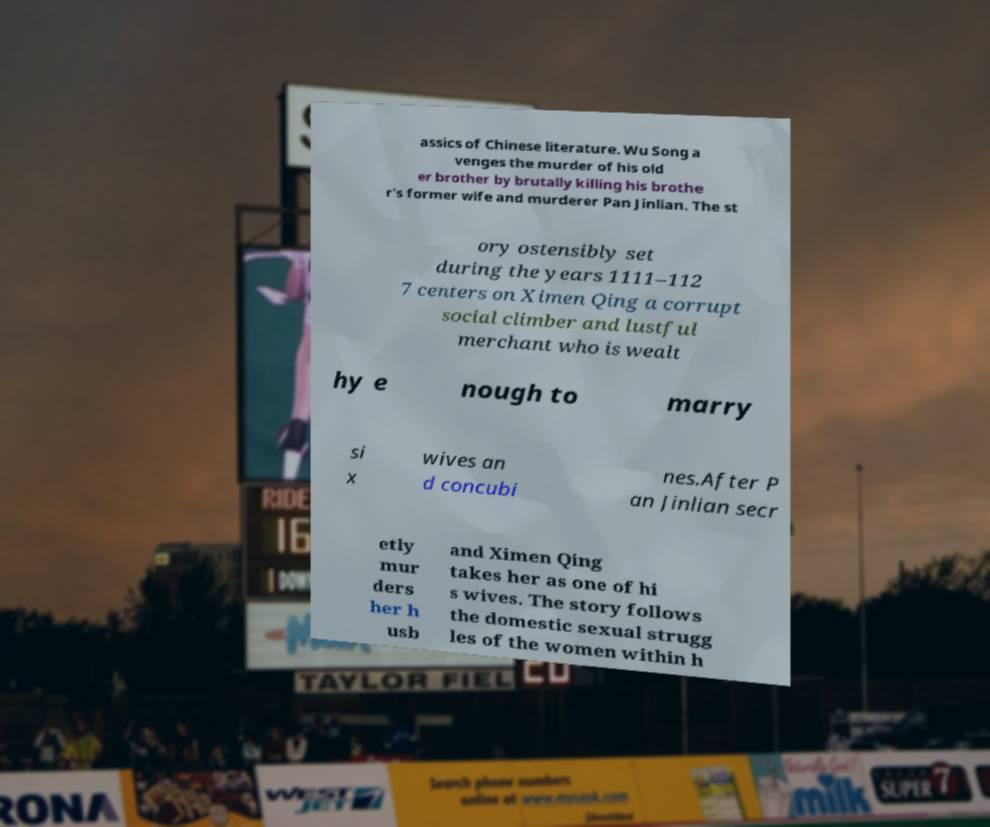I need the written content from this picture converted into text. Can you do that? assics of Chinese literature. Wu Song a venges the murder of his old er brother by brutally killing his brothe r's former wife and murderer Pan Jinlian. The st ory ostensibly set during the years 1111–112 7 centers on Ximen Qing a corrupt social climber and lustful merchant who is wealt hy e nough to marry si x wives an d concubi nes.After P an Jinlian secr etly mur ders her h usb and Ximen Qing takes her as one of hi s wives. The story follows the domestic sexual strugg les of the women within h 